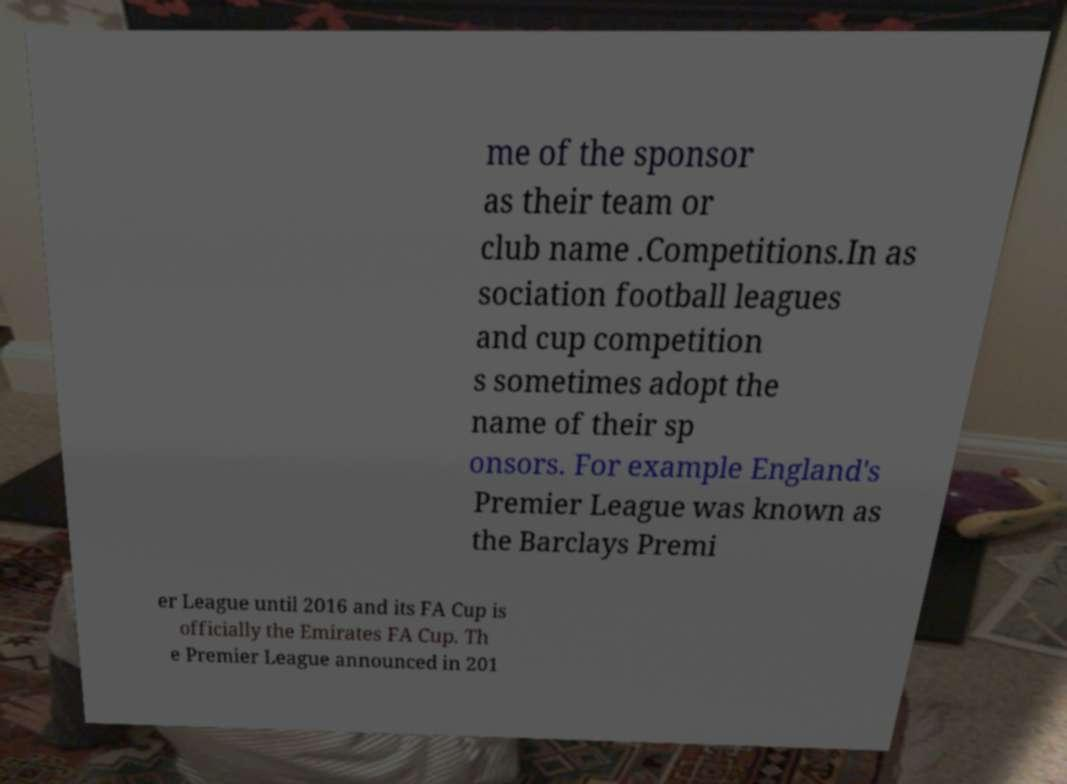What messages or text are displayed in this image? I need them in a readable, typed format. me of the sponsor as their team or club name .Competitions.In as sociation football leagues and cup competition s sometimes adopt the name of their sp onsors. For example England's Premier League was known as the Barclays Premi er League until 2016 and its FA Cup is officially the Emirates FA Cup. Th e Premier League announced in 201 